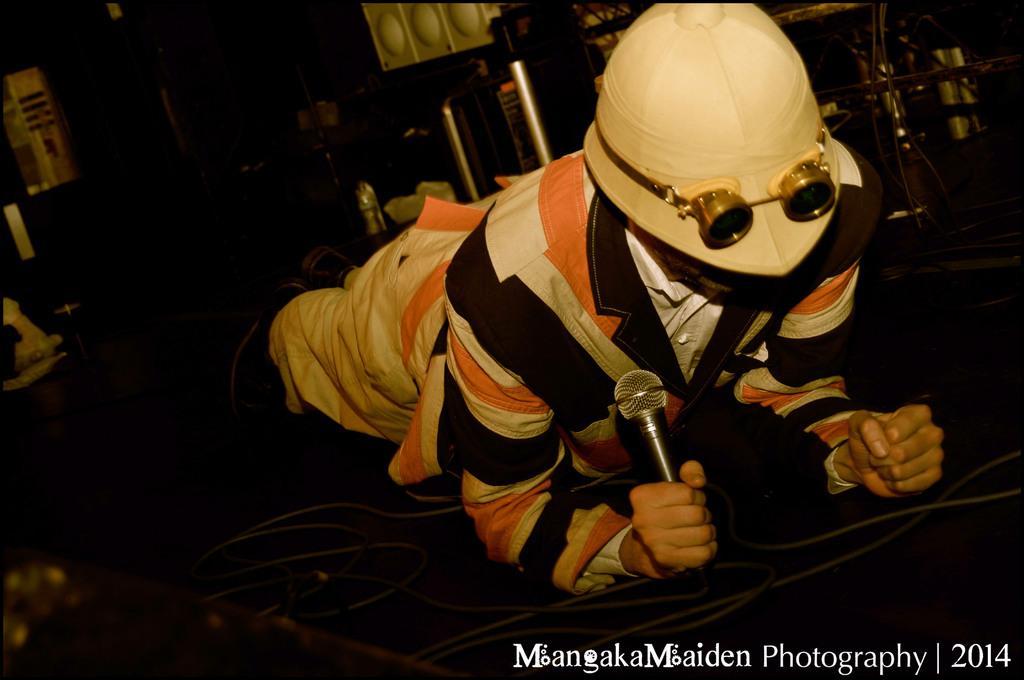In one or two sentences, can you explain what this image depicts? In this image there is a person wearing a helmet is holding a mic in his hand. 